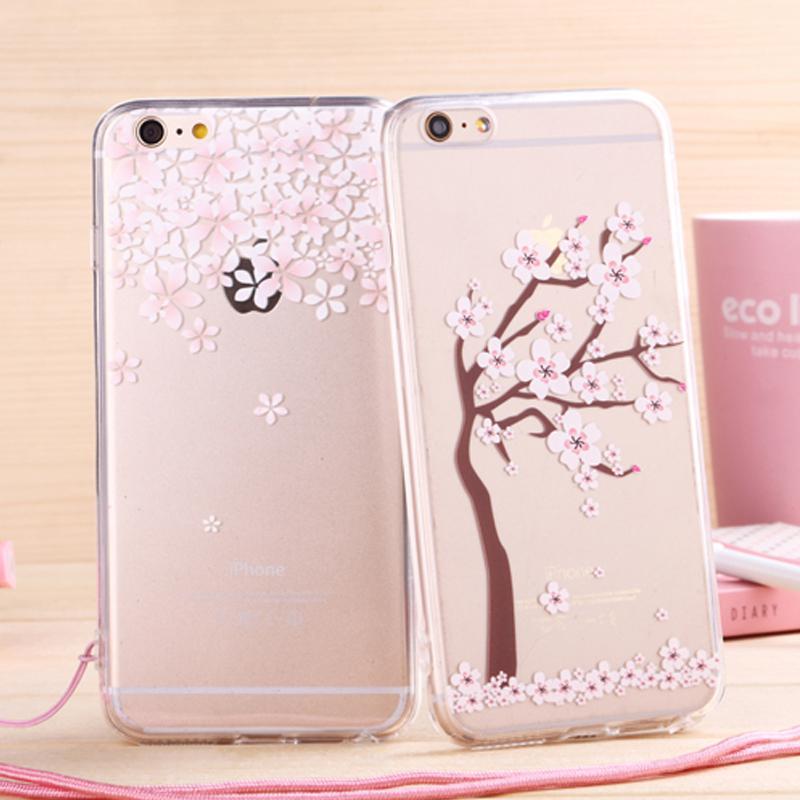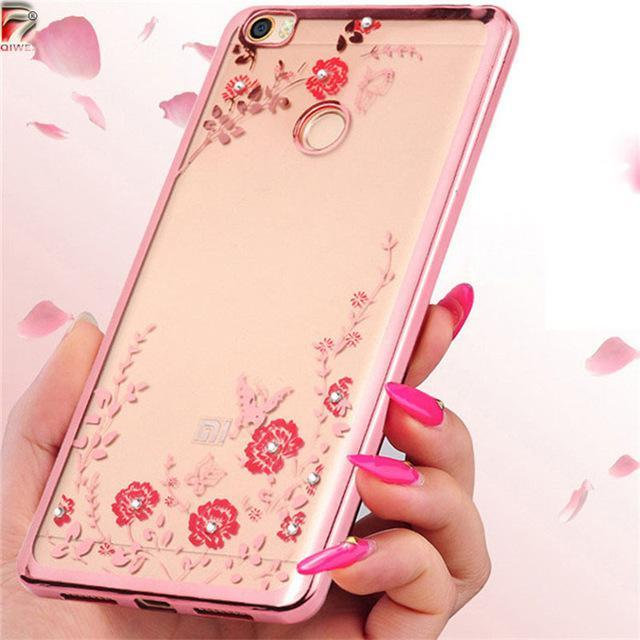The first image is the image on the left, the second image is the image on the right. Evaluate the accuracy of this statement regarding the images: "All of the iPhone cases in the images have a clear back that is decorated with flower blossoms.". Is it true? Answer yes or no. Yes. The first image is the image on the left, the second image is the image on the right. Given the left and right images, does the statement "The right image shows a rectangular device decorated with a cartoon cat face and at least one paw print." hold true? Answer yes or no. No. 